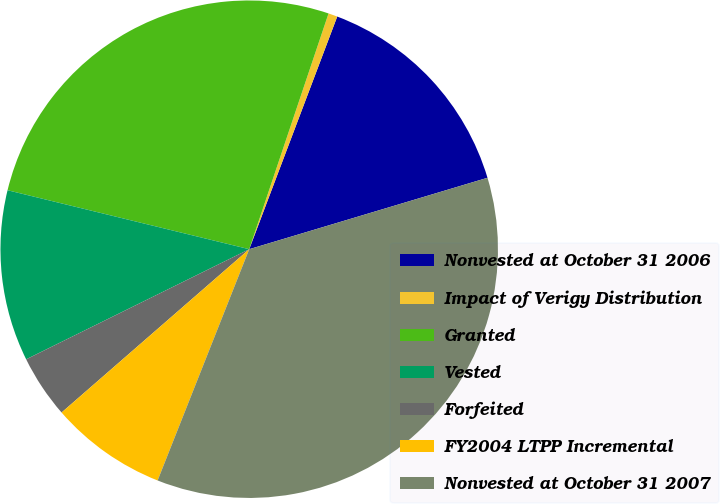Convert chart. <chart><loc_0><loc_0><loc_500><loc_500><pie_chart><fcel>Nonvested at October 31 2006<fcel>Impact of Verigy Distribution<fcel>Granted<fcel>Vested<fcel>Forfeited<fcel>FY2004 LTPP Incremental<fcel>Nonvested at October 31 2007<nl><fcel>14.61%<fcel>0.59%<fcel>26.36%<fcel>11.11%<fcel>4.1%<fcel>7.6%<fcel>35.64%<nl></chart> 